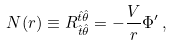Convert formula to latex. <formula><loc_0><loc_0><loc_500><loc_500>N ( r ) \equiv R _ { \hat { t } \hat { \theta } } ^ { \hat { t } \hat { \theta } } = - \frac { V } { r } \Phi ^ { \prime } \, ,</formula> 